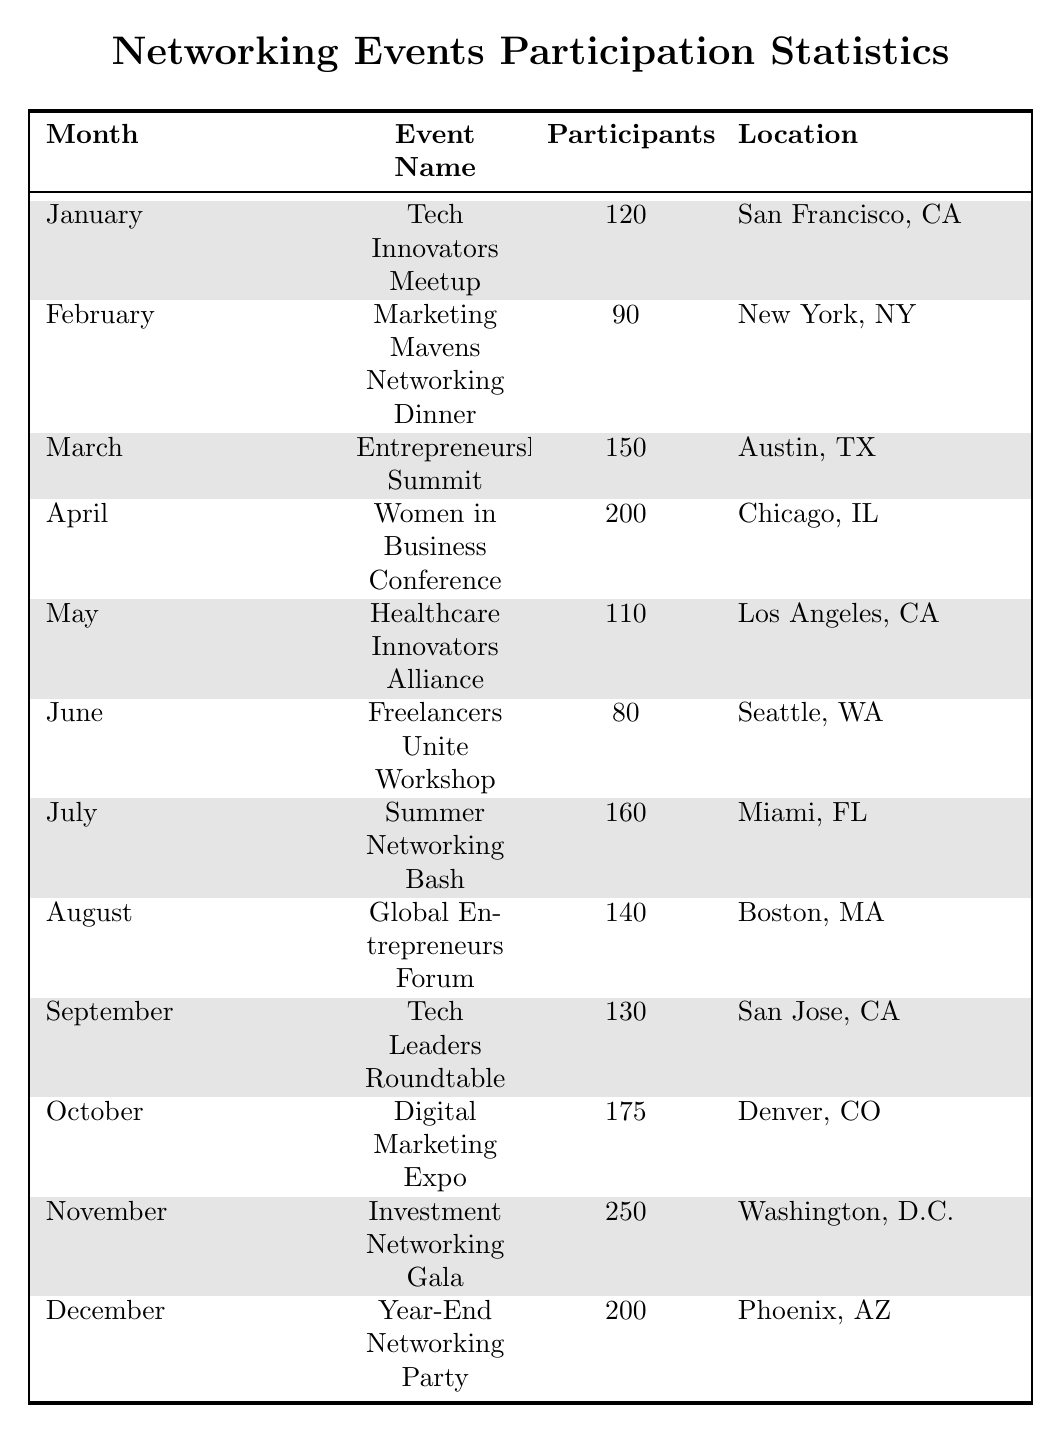What was the event with the highest participation? By reviewing the "Participants" column, I see that "Investment Networking Gala" has the highest number with 250 participants in November.
Answer: Investment Networking Gala How many participants attended the "Digital Marketing Expo"? Looking at the table, I find that "Digital Marketing Expo" had 175 participants in October.
Answer: 175 What is the average number of participants across all events? First, I sum all participant numbers: 120 + 90 + 150 + 200 + 110 + 80 + 160 + 140 + 130 + 175 + 250 + 200 = 1,675. Then, I divide by the number of events (12): 1,675 / 12 ≈ 139.58, so the average is approximately 140 when rounded.
Answer: 140 Was there an event in June with over 100 participants? In June, the "Freelancers Unite Workshop" had only 80 participants, which is less than 100, so the answer is no.
Answer: No What is the total number of participants from April to September? The participants are: April (200), May (110), June (80), July (160), August (140), and September (130). Summing these gives 200 + 110 + 80 + 160 + 140 + 130 = 920.
Answer: 920 Which event had fewer participants: "Tech Innovators Meetup" or "Marketing Mavens Networking Dinner"? "Tech Innovators Meetup" had 120 participants, while "Marketing Mavens Networking Dinner" had 90. Comparing these, the latter had fewer participants.
Answer: Marketing Mavens Networking Dinner How many events had more than 150 participants? The events with more than 150 participants include: "Entrepreneurship Summit" (150), "Women in Business Conference" (200), "Summer Networking Bash" (160), "Digital Marketing Expo" (175), and "Investment Networking Gala" (250), which totals 5 events.
Answer: 5 What was the total participation in the event locations of San Francisco and Miami? The participants in San Francisco (Tech Innovators Meetup) is 120, and in Miami (Summer Networking Bash) it is 160. Adding these: 120 + 160 = 280.
Answer: 280 Which month had the lowest participation, and how many participants were there? The month with the lowest participation is June, with only 80 participants in the "Freelancers Unite Workshop".
Answer: June, 80 If I wanted to attend an event in Chicago, what would be the participant count? The event in Chicago is the "Women in Business Conference," which had 200 participants.
Answer: 200 How does the participation in November compare to the average participation across all events? November had 250 participants in the "Investment Networking Gala." The average participation is approximately 140. Since 250 is greater than 140, November's participation was higher than average.
Answer: Higher than average 